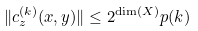<formula> <loc_0><loc_0><loc_500><loc_500>\| c _ { z } ^ { ( k ) } ( x , y ) \| \leq 2 ^ { \dim ( X ) } p ( k )</formula> 